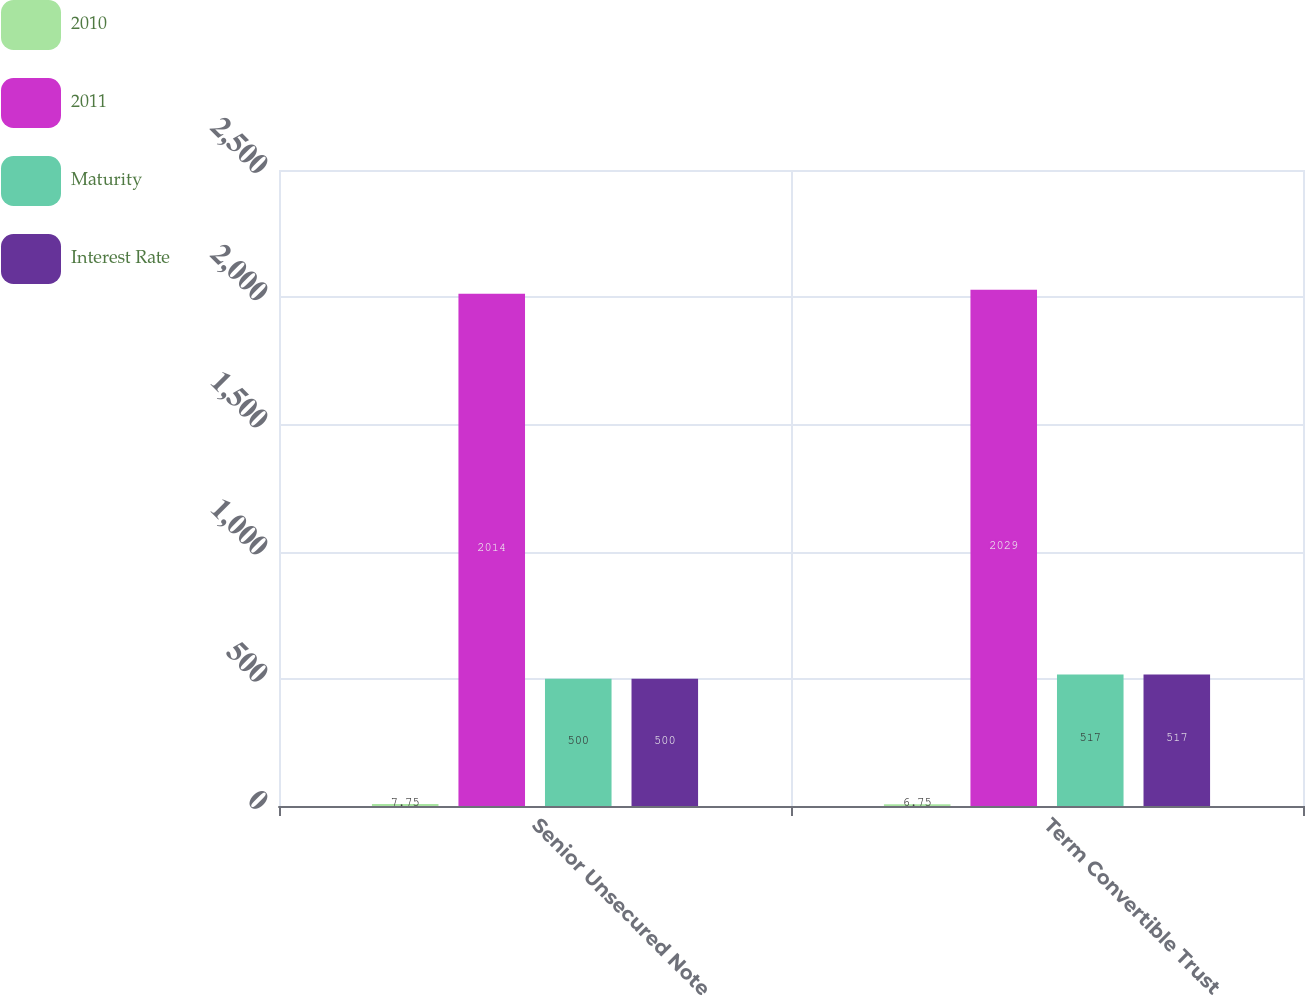<chart> <loc_0><loc_0><loc_500><loc_500><stacked_bar_chart><ecel><fcel>Senior Unsecured Note<fcel>Term Convertible Trust<nl><fcel>2010<fcel>7.75<fcel>6.75<nl><fcel>2011<fcel>2014<fcel>2029<nl><fcel>Maturity<fcel>500<fcel>517<nl><fcel>Interest Rate<fcel>500<fcel>517<nl></chart> 